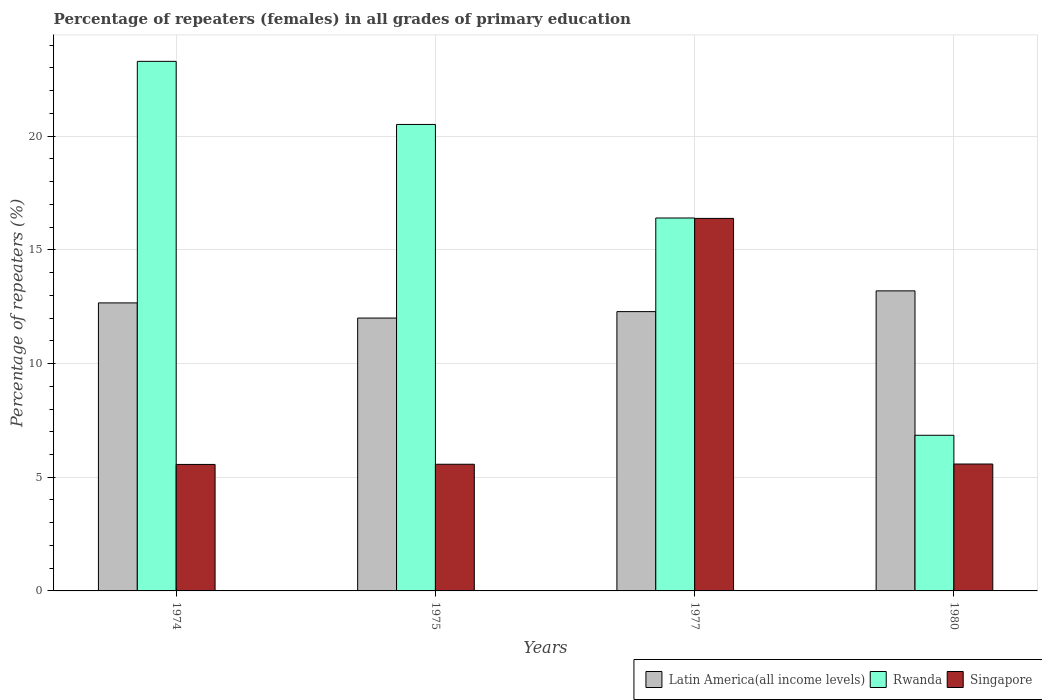How many different coloured bars are there?
Ensure brevity in your answer.  3. Are the number of bars on each tick of the X-axis equal?
Provide a short and direct response. Yes. How many bars are there on the 4th tick from the right?
Your response must be concise. 3. In how many cases, is the number of bars for a given year not equal to the number of legend labels?
Offer a terse response. 0. What is the percentage of repeaters (females) in Latin America(all income levels) in 1977?
Offer a very short reply. 12.28. Across all years, what is the maximum percentage of repeaters (females) in Rwanda?
Your answer should be very brief. 23.29. Across all years, what is the minimum percentage of repeaters (females) in Rwanda?
Keep it short and to the point. 6.85. In which year was the percentage of repeaters (females) in Latin America(all income levels) minimum?
Ensure brevity in your answer.  1975. What is the total percentage of repeaters (females) in Rwanda in the graph?
Keep it short and to the point. 67.05. What is the difference between the percentage of repeaters (females) in Latin America(all income levels) in 1974 and that in 1977?
Your answer should be compact. 0.38. What is the difference between the percentage of repeaters (females) in Latin America(all income levels) in 1977 and the percentage of repeaters (females) in Rwanda in 1980?
Provide a succinct answer. 5.44. What is the average percentage of repeaters (females) in Singapore per year?
Ensure brevity in your answer.  8.27. In the year 1975, what is the difference between the percentage of repeaters (females) in Latin America(all income levels) and percentage of repeaters (females) in Rwanda?
Provide a short and direct response. -8.51. What is the ratio of the percentage of repeaters (females) in Singapore in 1974 to that in 1975?
Make the answer very short. 1. Is the difference between the percentage of repeaters (females) in Latin America(all income levels) in 1975 and 1980 greater than the difference between the percentage of repeaters (females) in Rwanda in 1975 and 1980?
Provide a succinct answer. No. What is the difference between the highest and the second highest percentage of repeaters (females) in Singapore?
Provide a succinct answer. 10.8. What is the difference between the highest and the lowest percentage of repeaters (females) in Rwanda?
Your answer should be very brief. 16.44. What does the 3rd bar from the left in 1975 represents?
Your response must be concise. Singapore. What does the 3rd bar from the right in 1974 represents?
Your response must be concise. Latin America(all income levels). Are all the bars in the graph horizontal?
Provide a short and direct response. No. What is the difference between two consecutive major ticks on the Y-axis?
Your answer should be compact. 5. Are the values on the major ticks of Y-axis written in scientific E-notation?
Provide a succinct answer. No. Does the graph contain any zero values?
Provide a succinct answer. No. How many legend labels are there?
Give a very brief answer. 3. How are the legend labels stacked?
Offer a terse response. Horizontal. What is the title of the graph?
Offer a terse response. Percentage of repeaters (females) in all grades of primary education. What is the label or title of the Y-axis?
Offer a terse response. Percentage of repeaters (%). What is the Percentage of repeaters (%) in Latin America(all income levels) in 1974?
Give a very brief answer. 12.67. What is the Percentage of repeaters (%) of Rwanda in 1974?
Keep it short and to the point. 23.29. What is the Percentage of repeaters (%) in Singapore in 1974?
Your response must be concise. 5.56. What is the Percentage of repeaters (%) in Latin America(all income levels) in 1975?
Provide a succinct answer. 12. What is the Percentage of repeaters (%) of Rwanda in 1975?
Provide a short and direct response. 20.51. What is the Percentage of repeaters (%) in Singapore in 1975?
Provide a short and direct response. 5.57. What is the Percentage of repeaters (%) of Latin America(all income levels) in 1977?
Ensure brevity in your answer.  12.28. What is the Percentage of repeaters (%) in Rwanda in 1977?
Your answer should be compact. 16.4. What is the Percentage of repeaters (%) in Singapore in 1977?
Make the answer very short. 16.38. What is the Percentage of repeaters (%) in Latin America(all income levels) in 1980?
Your response must be concise. 13.2. What is the Percentage of repeaters (%) of Rwanda in 1980?
Keep it short and to the point. 6.85. What is the Percentage of repeaters (%) of Singapore in 1980?
Your answer should be compact. 5.58. Across all years, what is the maximum Percentage of repeaters (%) in Latin America(all income levels)?
Provide a succinct answer. 13.2. Across all years, what is the maximum Percentage of repeaters (%) of Rwanda?
Your answer should be compact. 23.29. Across all years, what is the maximum Percentage of repeaters (%) of Singapore?
Make the answer very short. 16.38. Across all years, what is the minimum Percentage of repeaters (%) in Latin America(all income levels)?
Ensure brevity in your answer.  12. Across all years, what is the minimum Percentage of repeaters (%) of Rwanda?
Your response must be concise. 6.85. Across all years, what is the minimum Percentage of repeaters (%) in Singapore?
Give a very brief answer. 5.56. What is the total Percentage of repeaters (%) in Latin America(all income levels) in the graph?
Your answer should be compact. 50.14. What is the total Percentage of repeaters (%) in Rwanda in the graph?
Give a very brief answer. 67.05. What is the total Percentage of repeaters (%) in Singapore in the graph?
Ensure brevity in your answer.  33.09. What is the difference between the Percentage of repeaters (%) in Rwanda in 1974 and that in 1975?
Keep it short and to the point. 2.77. What is the difference between the Percentage of repeaters (%) of Singapore in 1974 and that in 1975?
Provide a short and direct response. -0.01. What is the difference between the Percentage of repeaters (%) in Latin America(all income levels) in 1974 and that in 1977?
Give a very brief answer. 0.38. What is the difference between the Percentage of repeaters (%) of Rwanda in 1974 and that in 1977?
Your answer should be compact. 6.89. What is the difference between the Percentage of repeaters (%) in Singapore in 1974 and that in 1977?
Your answer should be compact. -10.82. What is the difference between the Percentage of repeaters (%) in Latin America(all income levels) in 1974 and that in 1980?
Your answer should be compact. -0.53. What is the difference between the Percentage of repeaters (%) of Rwanda in 1974 and that in 1980?
Your response must be concise. 16.44. What is the difference between the Percentage of repeaters (%) in Singapore in 1974 and that in 1980?
Ensure brevity in your answer.  -0.02. What is the difference between the Percentage of repeaters (%) in Latin America(all income levels) in 1975 and that in 1977?
Ensure brevity in your answer.  -0.28. What is the difference between the Percentage of repeaters (%) of Rwanda in 1975 and that in 1977?
Your response must be concise. 4.11. What is the difference between the Percentage of repeaters (%) in Singapore in 1975 and that in 1977?
Make the answer very short. -10.81. What is the difference between the Percentage of repeaters (%) in Latin America(all income levels) in 1975 and that in 1980?
Your answer should be very brief. -1.2. What is the difference between the Percentage of repeaters (%) of Rwanda in 1975 and that in 1980?
Your answer should be very brief. 13.67. What is the difference between the Percentage of repeaters (%) in Singapore in 1975 and that in 1980?
Offer a terse response. -0.01. What is the difference between the Percentage of repeaters (%) of Latin America(all income levels) in 1977 and that in 1980?
Offer a very short reply. -0.91. What is the difference between the Percentage of repeaters (%) of Rwanda in 1977 and that in 1980?
Make the answer very short. 9.56. What is the difference between the Percentage of repeaters (%) of Singapore in 1977 and that in 1980?
Ensure brevity in your answer.  10.8. What is the difference between the Percentage of repeaters (%) of Latin America(all income levels) in 1974 and the Percentage of repeaters (%) of Rwanda in 1975?
Provide a short and direct response. -7.85. What is the difference between the Percentage of repeaters (%) of Latin America(all income levels) in 1974 and the Percentage of repeaters (%) of Singapore in 1975?
Ensure brevity in your answer.  7.1. What is the difference between the Percentage of repeaters (%) of Rwanda in 1974 and the Percentage of repeaters (%) of Singapore in 1975?
Ensure brevity in your answer.  17.72. What is the difference between the Percentage of repeaters (%) of Latin America(all income levels) in 1974 and the Percentage of repeaters (%) of Rwanda in 1977?
Give a very brief answer. -3.73. What is the difference between the Percentage of repeaters (%) in Latin America(all income levels) in 1974 and the Percentage of repeaters (%) in Singapore in 1977?
Your answer should be compact. -3.72. What is the difference between the Percentage of repeaters (%) of Rwanda in 1974 and the Percentage of repeaters (%) of Singapore in 1977?
Your answer should be very brief. 6.91. What is the difference between the Percentage of repeaters (%) of Latin America(all income levels) in 1974 and the Percentage of repeaters (%) of Rwanda in 1980?
Offer a terse response. 5.82. What is the difference between the Percentage of repeaters (%) of Latin America(all income levels) in 1974 and the Percentage of repeaters (%) of Singapore in 1980?
Provide a short and direct response. 7.09. What is the difference between the Percentage of repeaters (%) in Rwanda in 1974 and the Percentage of repeaters (%) in Singapore in 1980?
Give a very brief answer. 17.71. What is the difference between the Percentage of repeaters (%) in Latin America(all income levels) in 1975 and the Percentage of repeaters (%) in Rwanda in 1977?
Provide a short and direct response. -4.4. What is the difference between the Percentage of repeaters (%) in Latin America(all income levels) in 1975 and the Percentage of repeaters (%) in Singapore in 1977?
Give a very brief answer. -4.38. What is the difference between the Percentage of repeaters (%) of Rwanda in 1975 and the Percentage of repeaters (%) of Singapore in 1977?
Provide a short and direct response. 4.13. What is the difference between the Percentage of repeaters (%) in Latin America(all income levels) in 1975 and the Percentage of repeaters (%) in Rwanda in 1980?
Make the answer very short. 5.15. What is the difference between the Percentage of repeaters (%) in Latin America(all income levels) in 1975 and the Percentage of repeaters (%) in Singapore in 1980?
Keep it short and to the point. 6.42. What is the difference between the Percentage of repeaters (%) in Rwanda in 1975 and the Percentage of repeaters (%) in Singapore in 1980?
Your response must be concise. 14.93. What is the difference between the Percentage of repeaters (%) of Latin America(all income levels) in 1977 and the Percentage of repeaters (%) of Rwanda in 1980?
Make the answer very short. 5.44. What is the difference between the Percentage of repeaters (%) in Latin America(all income levels) in 1977 and the Percentage of repeaters (%) in Singapore in 1980?
Ensure brevity in your answer.  6.7. What is the difference between the Percentage of repeaters (%) of Rwanda in 1977 and the Percentage of repeaters (%) of Singapore in 1980?
Provide a succinct answer. 10.82. What is the average Percentage of repeaters (%) of Latin America(all income levels) per year?
Offer a very short reply. 12.54. What is the average Percentage of repeaters (%) in Rwanda per year?
Your answer should be very brief. 16.76. What is the average Percentage of repeaters (%) in Singapore per year?
Your answer should be compact. 8.27. In the year 1974, what is the difference between the Percentage of repeaters (%) of Latin America(all income levels) and Percentage of repeaters (%) of Rwanda?
Keep it short and to the point. -10.62. In the year 1974, what is the difference between the Percentage of repeaters (%) of Latin America(all income levels) and Percentage of repeaters (%) of Singapore?
Give a very brief answer. 7.1. In the year 1974, what is the difference between the Percentage of repeaters (%) in Rwanda and Percentage of repeaters (%) in Singapore?
Provide a succinct answer. 17.73. In the year 1975, what is the difference between the Percentage of repeaters (%) of Latin America(all income levels) and Percentage of repeaters (%) of Rwanda?
Offer a very short reply. -8.51. In the year 1975, what is the difference between the Percentage of repeaters (%) in Latin America(all income levels) and Percentage of repeaters (%) in Singapore?
Ensure brevity in your answer.  6.43. In the year 1975, what is the difference between the Percentage of repeaters (%) in Rwanda and Percentage of repeaters (%) in Singapore?
Ensure brevity in your answer.  14.94. In the year 1977, what is the difference between the Percentage of repeaters (%) in Latin America(all income levels) and Percentage of repeaters (%) in Rwanda?
Provide a succinct answer. -4.12. In the year 1977, what is the difference between the Percentage of repeaters (%) in Latin America(all income levels) and Percentage of repeaters (%) in Singapore?
Provide a short and direct response. -4.1. In the year 1977, what is the difference between the Percentage of repeaters (%) in Rwanda and Percentage of repeaters (%) in Singapore?
Your answer should be very brief. 0.02. In the year 1980, what is the difference between the Percentage of repeaters (%) of Latin America(all income levels) and Percentage of repeaters (%) of Rwanda?
Give a very brief answer. 6.35. In the year 1980, what is the difference between the Percentage of repeaters (%) in Latin America(all income levels) and Percentage of repeaters (%) in Singapore?
Keep it short and to the point. 7.62. In the year 1980, what is the difference between the Percentage of repeaters (%) of Rwanda and Percentage of repeaters (%) of Singapore?
Keep it short and to the point. 1.26. What is the ratio of the Percentage of repeaters (%) of Latin America(all income levels) in 1974 to that in 1975?
Offer a very short reply. 1.06. What is the ratio of the Percentage of repeaters (%) of Rwanda in 1974 to that in 1975?
Provide a short and direct response. 1.14. What is the ratio of the Percentage of repeaters (%) of Latin America(all income levels) in 1974 to that in 1977?
Your answer should be very brief. 1.03. What is the ratio of the Percentage of repeaters (%) in Rwanda in 1974 to that in 1977?
Your answer should be very brief. 1.42. What is the ratio of the Percentage of repeaters (%) in Singapore in 1974 to that in 1977?
Provide a succinct answer. 0.34. What is the ratio of the Percentage of repeaters (%) of Latin America(all income levels) in 1974 to that in 1980?
Provide a succinct answer. 0.96. What is the ratio of the Percentage of repeaters (%) in Rwanda in 1974 to that in 1980?
Provide a short and direct response. 3.4. What is the ratio of the Percentage of repeaters (%) of Singapore in 1974 to that in 1980?
Your answer should be very brief. 1. What is the ratio of the Percentage of repeaters (%) of Latin America(all income levels) in 1975 to that in 1977?
Your answer should be compact. 0.98. What is the ratio of the Percentage of repeaters (%) in Rwanda in 1975 to that in 1977?
Keep it short and to the point. 1.25. What is the ratio of the Percentage of repeaters (%) in Singapore in 1975 to that in 1977?
Keep it short and to the point. 0.34. What is the ratio of the Percentage of repeaters (%) in Latin America(all income levels) in 1975 to that in 1980?
Offer a very short reply. 0.91. What is the ratio of the Percentage of repeaters (%) of Rwanda in 1975 to that in 1980?
Offer a terse response. 3. What is the ratio of the Percentage of repeaters (%) in Latin America(all income levels) in 1977 to that in 1980?
Ensure brevity in your answer.  0.93. What is the ratio of the Percentage of repeaters (%) in Rwanda in 1977 to that in 1980?
Keep it short and to the point. 2.4. What is the ratio of the Percentage of repeaters (%) in Singapore in 1977 to that in 1980?
Your answer should be compact. 2.94. What is the difference between the highest and the second highest Percentage of repeaters (%) in Latin America(all income levels)?
Give a very brief answer. 0.53. What is the difference between the highest and the second highest Percentage of repeaters (%) of Rwanda?
Your answer should be compact. 2.77. What is the difference between the highest and the second highest Percentage of repeaters (%) in Singapore?
Offer a terse response. 10.8. What is the difference between the highest and the lowest Percentage of repeaters (%) of Latin America(all income levels)?
Give a very brief answer. 1.2. What is the difference between the highest and the lowest Percentage of repeaters (%) in Rwanda?
Make the answer very short. 16.44. What is the difference between the highest and the lowest Percentage of repeaters (%) in Singapore?
Give a very brief answer. 10.82. 